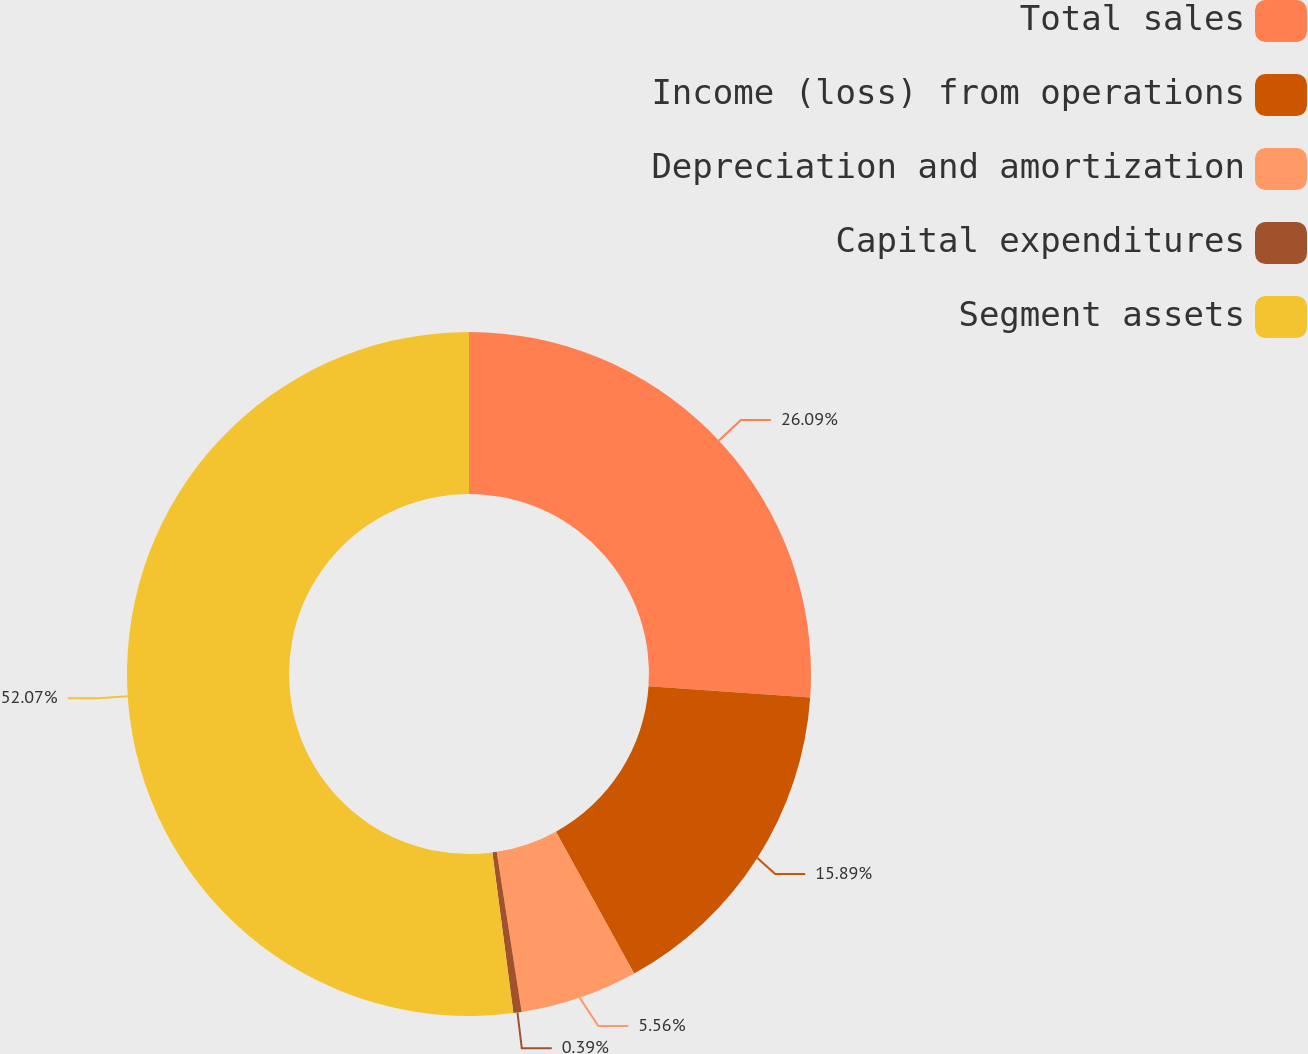Convert chart to OTSL. <chart><loc_0><loc_0><loc_500><loc_500><pie_chart><fcel>Total sales<fcel>Income (loss) from operations<fcel>Depreciation and amortization<fcel>Capital expenditures<fcel>Segment assets<nl><fcel>26.09%<fcel>15.89%<fcel>5.56%<fcel>0.39%<fcel>52.07%<nl></chart> 